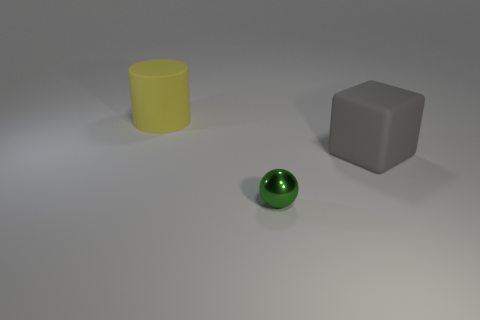What color is the big block that is the same material as the large yellow object?
Provide a succinct answer. Gray. There is a rubber object left of the big gray rubber object; what size is it?
Provide a succinct answer. Large. Are there fewer large things that are on the right side of the gray matte cube than large yellow matte cylinders?
Give a very brief answer. Yes. Are there any other things that are the same shape as the big yellow matte thing?
Keep it short and to the point. No. Are there fewer red cylinders than yellow cylinders?
Offer a terse response. Yes. What is the color of the matte object that is on the left side of the large matte thing that is in front of the yellow matte object?
Make the answer very short. Yellow. What is the material of the object in front of the big object right of the thing behind the gray rubber block?
Provide a succinct answer. Metal. Do the matte object that is to the right of the rubber cylinder and the green metal object have the same size?
Offer a very short reply. No. What is the thing that is in front of the large gray rubber thing made of?
Give a very brief answer. Metal. Is the number of tiny spheres greater than the number of big green spheres?
Your answer should be very brief. Yes. 